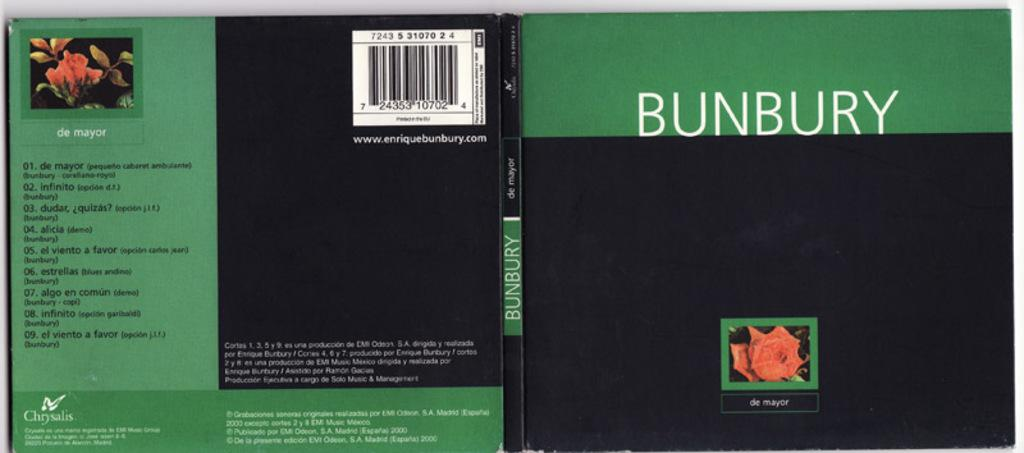<image>
Give a short and clear explanation of the subsequent image. A black and green book is entitled "Bunbury." 